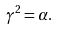Convert formula to latex. <formula><loc_0><loc_0><loc_500><loc_500>\gamma ^ { 2 } = \alpha .</formula> 